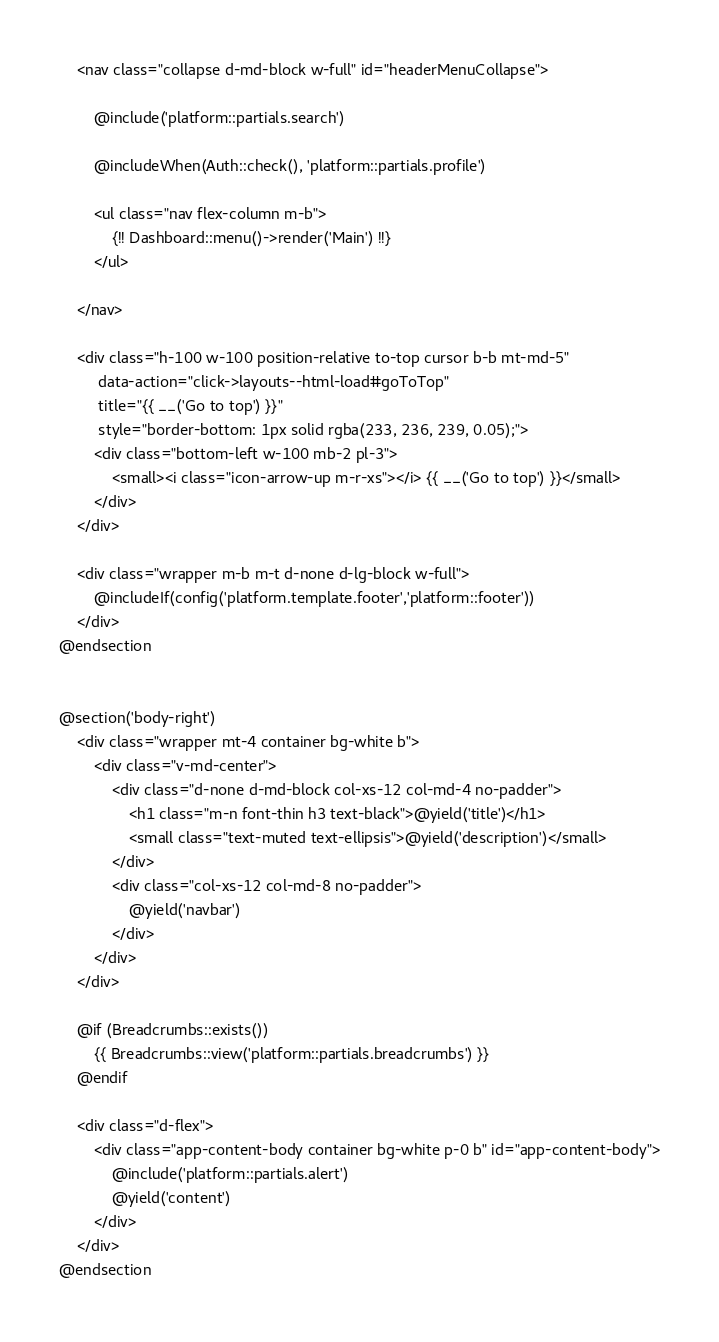Convert code to text. <code><loc_0><loc_0><loc_500><loc_500><_PHP_>    <nav class="collapse d-md-block w-full" id="headerMenuCollapse">

        @include('platform::partials.search')

        @includeWhen(Auth::check(), 'platform::partials.profile')

        <ul class="nav flex-column m-b">
            {!! Dashboard::menu()->render('Main') !!}
        </ul>

    </nav>

    <div class="h-100 w-100 position-relative to-top cursor b-b mt-md-5"
         data-action="click->layouts--html-load#goToTop"
         title="{{ __('Go to top') }}"
         style="border-bottom: 1px solid rgba(233, 236, 239, 0.05);">
        <div class="bottom-left w-100 mb-2 pl-3">
            <small><i class="icon-arrow-up m-r-xs"></i> {{ __('Go to top') }}</small>
        </div>
    </div>

    <div class="wrapper m-b m-t d-none d-lg-block w-full">
        @includeIf(config('platform.template.footer','platform::footer'))
    </div>
@endsection


@section('body-right')
    <div class="wrapper mt-4 container bg-white b">
        <div class="v-md-center">
            <div class="d-none d-md-block col-xs-12 col-md-4 no-padder">
                <h1 class="m-n font-thin h3 text-black">@yield('title')</h1>
                <small class="text-muted text-ellipsis">@yield('description')</small>
            </div>
            <div class="col-xs-12 col-md-8 no-padder">
                @yield('navbar')
            </div>
        </div>
    </div>

    @if (Breadcrumbs::exists())
        {{ Breadcrumbs::view('platform::partials.breadcrumbs') }}
    @endif

    <div class="d-flex">
        <div class="app-content-body container bg-white p-0 b" id="app-content-body">
            @include('platform::partials.alert')
            @yield('content')
        </div>
    </div>
@endsection
</code> 